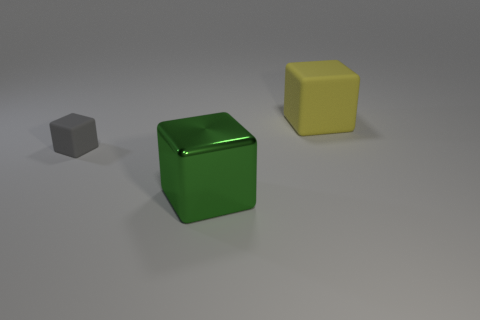Is there anything else that has the same material as the tiny cube?
Offer a very short reply. Yes. Are there any other things that are the same size as the gray rubber object?
Provide a succinct answer. No. How big is the object that is right of the large object in front of the yellow thing?
Provide a short and direct response. Large. The thing that is made of the same material as the tiny block is what size?
Offer a terse response. Large. What is the size of the thing that is behind the green block and right of the small gray matte thing?
Your answer should be very brief. Large. There is a object that is on the right side of the big block that is in front of the small thing; what number of metal things are left of it?
Your answer should be very brief. 1. What color is the shiny cube that is the same size as the yellow rubber cube?
Your answer should be very brief. Green. The large thing to the left of the rubber block to the right of the object on the left side of the green metallic object is what shape?
Offer a terse response. Cube. What number of blocks are behind the metal block on the right side of the gray block?
Keep it short and to the point. 2. Does the object that is to the right of the large metallic cube have the same shape as the thing that is in front of the tiny gray matte thing?
Your answer should be very brief. Yes. 